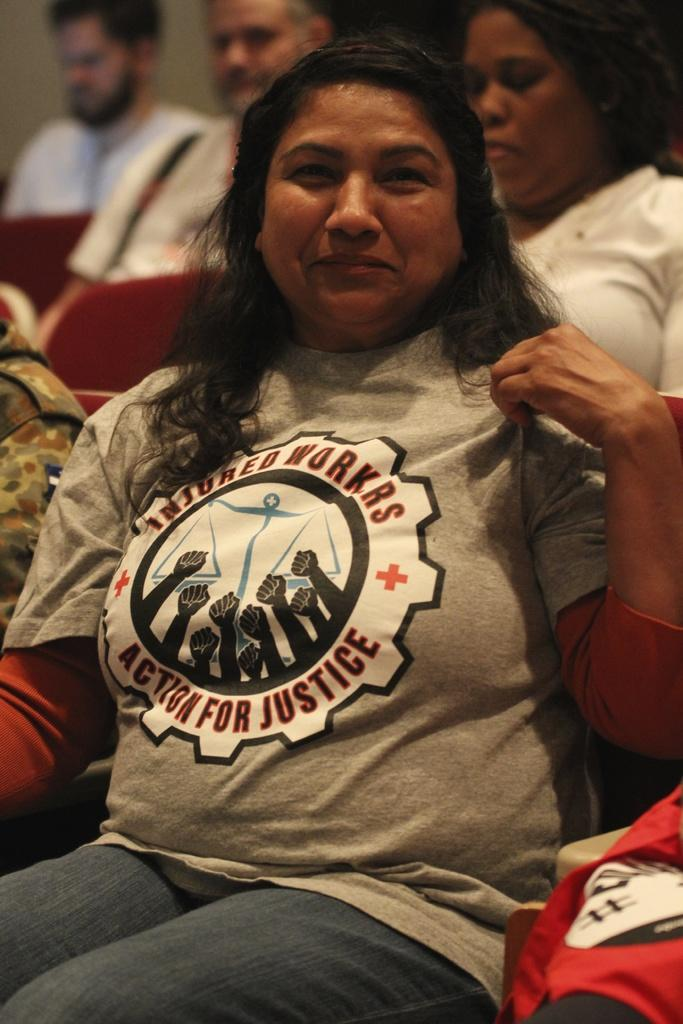<image>
Render a clear and concise summary of the photo. A woman wearing a shirt that says Injured workers action for justice. 